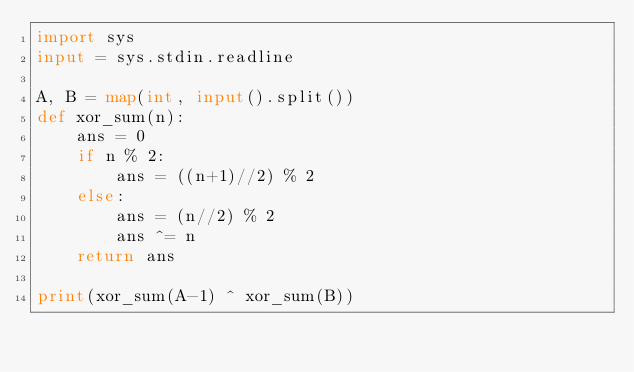Convert code to text. <code><loc_0><loc_0><loc_500><loc_500><_Python_>import sys
input = sys.stdin.readline

A, B = map(int, input().split())
def xor_sum(n):
    ans = 0
    if n % 2:
        ans = ((n+1)//2) % 2
    else:
        ans = (n//2) % 2
        ans ^= n
    return ans

print(xor_sum(A-1) ^ xor_sum(B))</code> 